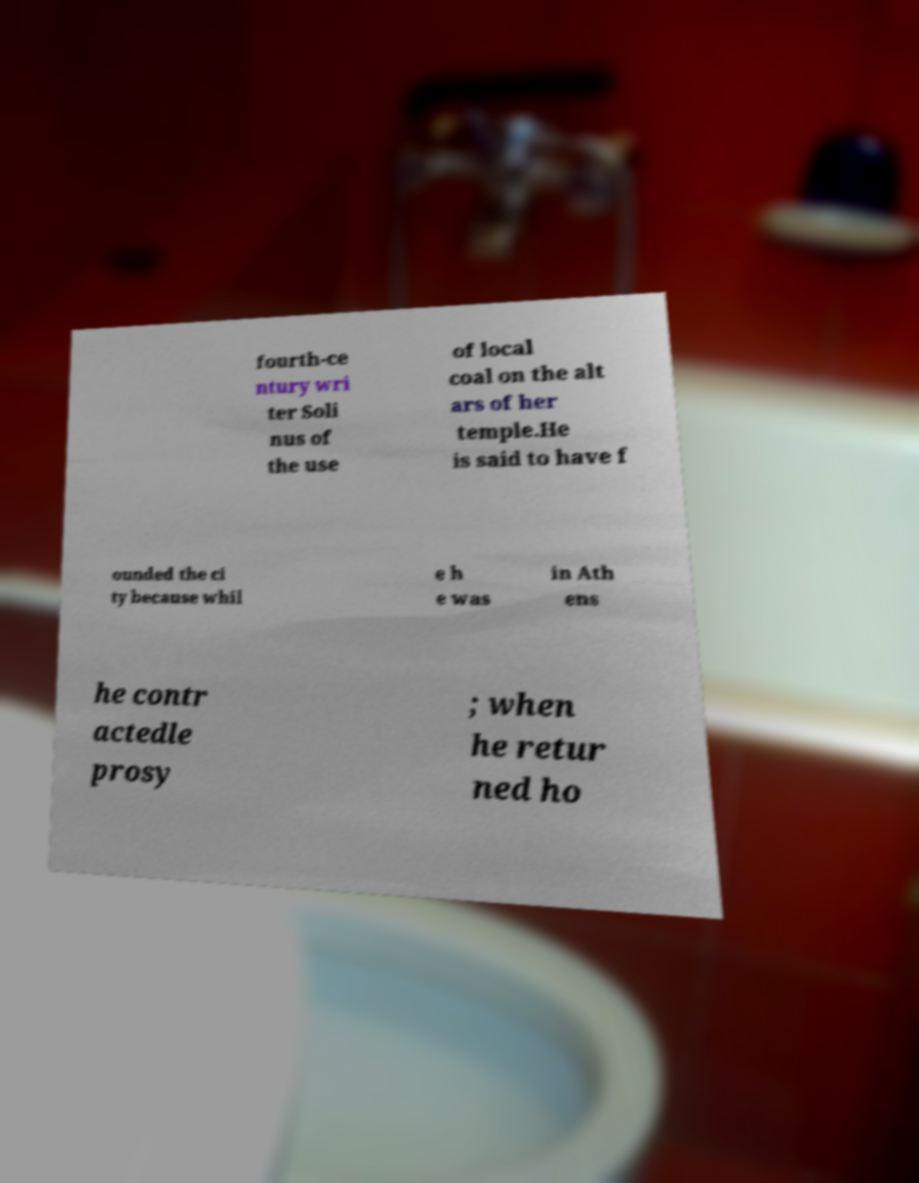Please identify and transcribe the text found in this image. fourth-ce ntury wri ter Soli nus of the use of local coal on the alt ars of her temple.He is said to have f ounded the ci ty because whil e h e was in Ath ens he contr actedle prosy ; when he retur ned ho 